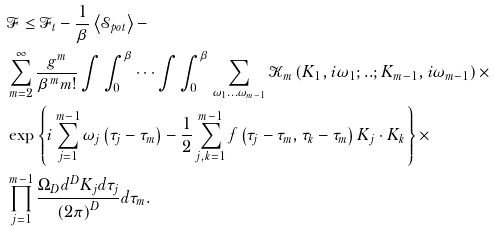<formula> <loc_0><loc_0><loc_500><loc_500>& \mathcal { F } \leq \mathcal { F } _ { t } - \frac { 1 } { \beta } \left \langle \mathcal { S } _ { p o t } \right \rangle - \\ & \sum _ { m = 2 } ^ { \infty } \frac { g ^ { m } } { \beta ^ { m } m ! } \int \int _ { 0 } ^ { \beta } \cdots \int \int _ { 0 } ^ { \beta } \sum _ { \omega _ { 1 } \dots \omega _ { m - 1 } } \mathcal { K } _ { m } \left ( K _ { 1 } , i \omega _ { 1 } ; . . ; K _ { m - 1 } , i \omega _ { m - 1 } \right ) \times \\ & \exp \left \{ i \sum _ { j = 1 } ^ { m - 1 } \omega _ { j } \left ( \tau _ { j } - \tau _ { m } \right ) - \frac { 1 } { 2 } \sum _ { j , k = 1 } ^ { m - 1 } f \left ( \tau _ { j } - \tau _ { m } , \tau _ { k } - \tau _ { m } \right ) K _ { j } \cdot K _ { k } \right \} \times \\ & \prod _ { j = 1 } ^ { m - 1 } \frac { \Omega _ { D } d ^ { D } K _ { j } d \tau _ { j } } { \left ( 2 \pi \right ) ^ { D } } d \tau _ { m } .</formula> 